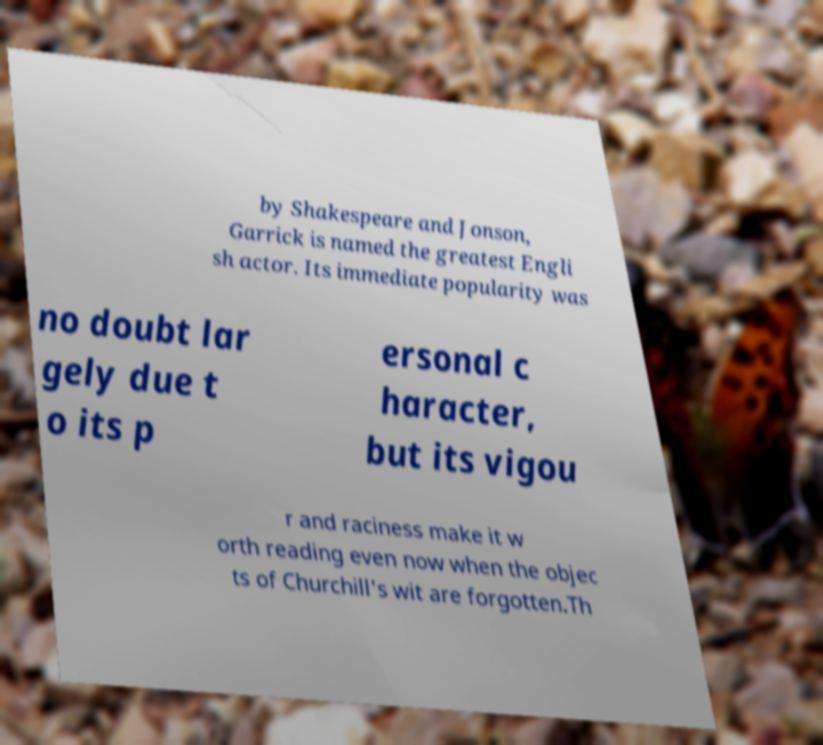I need the written content from this picture converted into text. Can you do that? by Shakespeare and Jonson, Garrick is named the greatest Engli sh actor. Its immediate popularity was no doubt lar gely due t o its p ersonal c haracter, but its vigou r and raciness make it w orth reading even now when the objec ts of Churchill's wit are forgotten.Th 